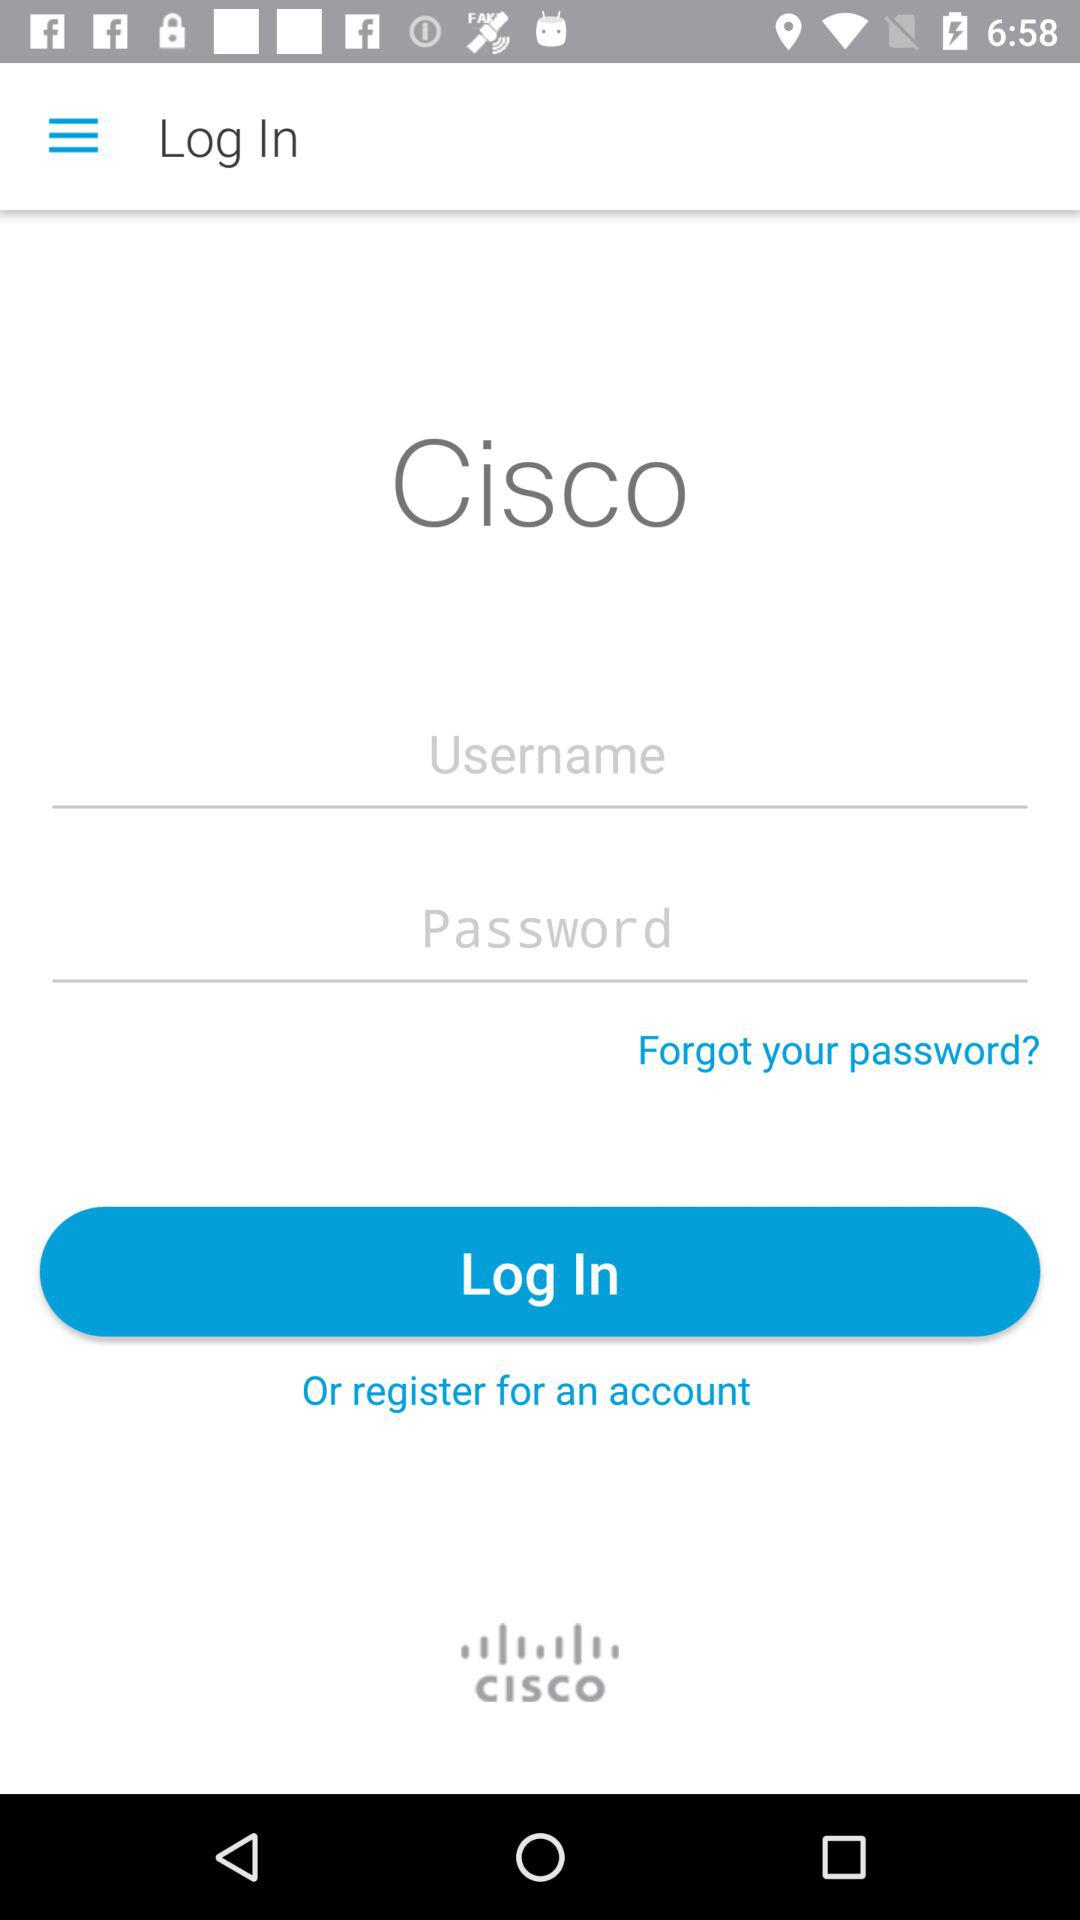How many fields are there for the user to enter their credentials?
Answer the question using a single word or phrase. 2 